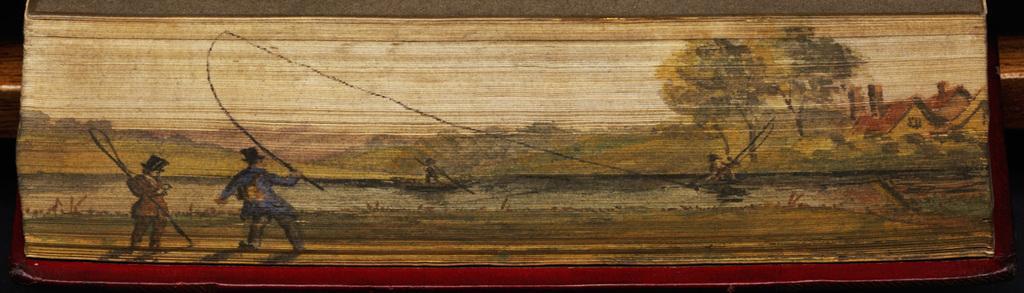Could you give a brief overview of what you see in this image? In this image we can see some persons holding fishing nets in their hands and at the background of the image there are some houses and trees. 